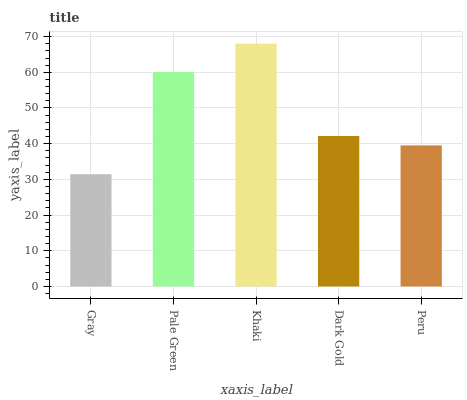Is Gray the minimum?
Answer yes or no. Yes. Is Khaki the maximum?
Answer yes or no. Yes. Is Pale Green the minimum?
Answer yes or no. No. Is Pale Green the maximum?
Answer yes or no. No. Is Pale Green greater than Gray?
Answer yes or no. Yes. Is Gray less than Pale Green?
Answer yes or no. Yes. Is Gray greater than Pale Green?
Answer yes or no. No. Is Pale Green less than Gray?
Answer yes or no. No. Is Dark Gold the high median?
Answer yes or no. Yes. Is Dark Gold the low median?
Answer yes or no. Yes. Is Khaki the high median?
Answer yes or no. No. Is Pale Green the low median?
Answer yes or no. No. 